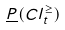<formula> <loc_0><loc_0><loc_500><loc_500>\underline { P } ( C l _ { t } ^ { \geq } )</formula> 